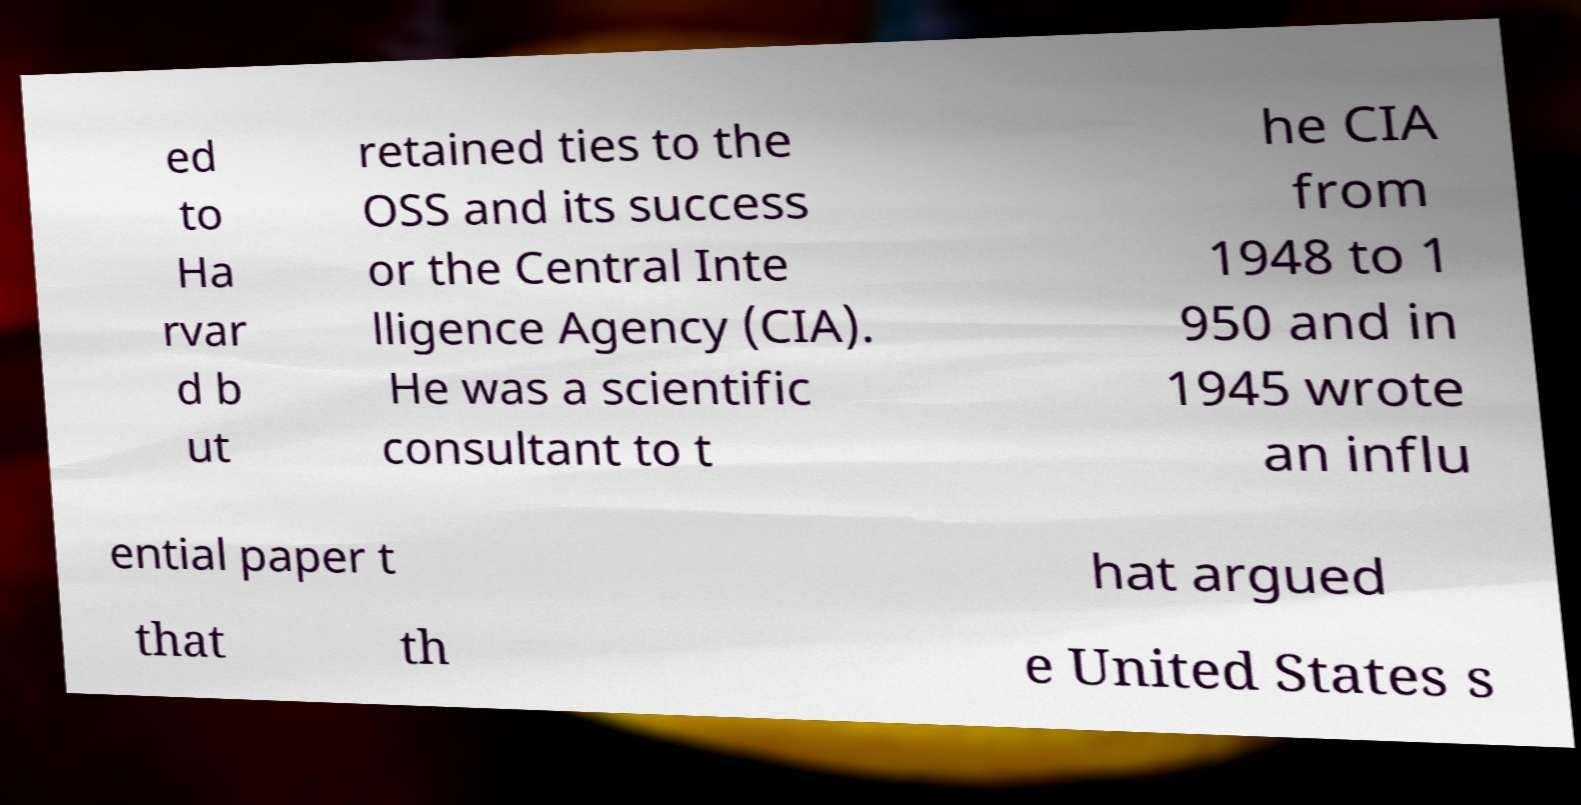Could you extract and type out the text from this image? ed to Ha rvar d b ut retained ties to the OSS and its success or the Central Inte lligence Agency (CIA). He was a scientific consultant to t he CIA from 1948 to 1 950 and in 1945 wrote an influ ential paper t hat argued that th e United States s 